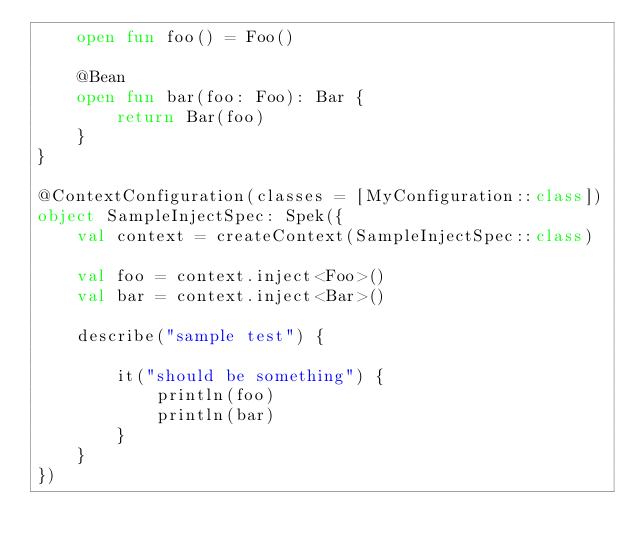<code> <loc_0><loc_0><loc_500><loc_500><_Kotlin_>    open fun foo() = Foo()

    @Bean
    open fun bar(foo: Foo): Bar {
        return Bar(foo)
    }
}

@ContextConfiguration(classes = [MyConfiguration::class])
object SampleInjectSpec: Spek({
    val context = createContext(SampleInjectSpec::class)

    val foo = context.inject<Foo>()
    val bar = context.inject<Bar>()

    describe("sample test") {

        it("should be something") {
            println(foo)
            println(bar)
        }
    }
})</code> 